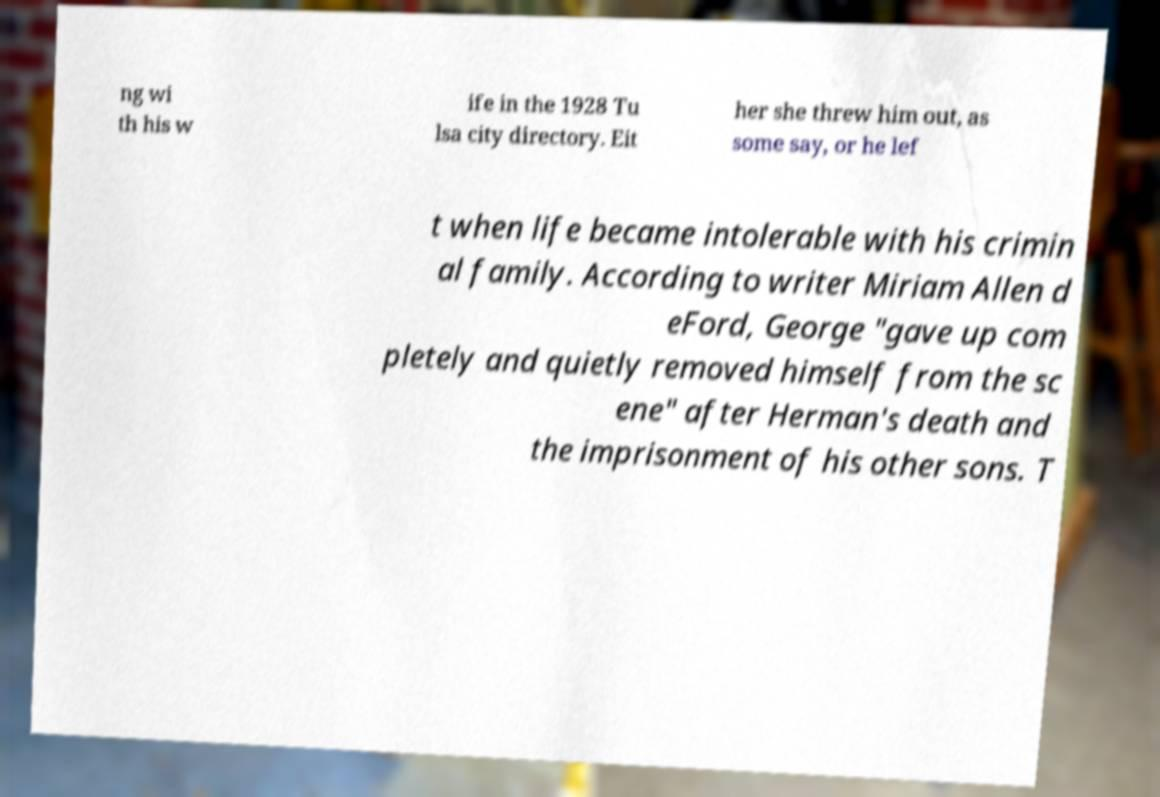What messages or text are displayed in this image? I need them in a readable, typed format. ng wi th his w ife in the 1928 Tu lsa city directory. Eit her she threw him out, as some say, or he lef t when life became intolerable with his crimin al family. According to writer Miriam Allen d eFord, George "gave up com pletely and quietly removed himself from the sc ene" after Herman's death and the imprisonment of his other sons. T 